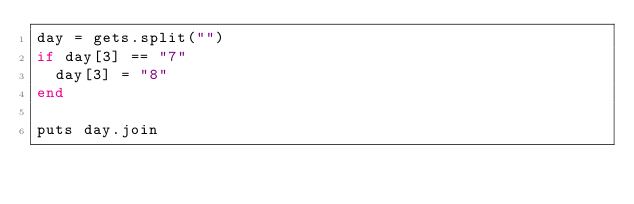<code> <loc_0><loc_0><loc_500><loc_500><_Ruby_>day = gets.split("")
if day[3] == "7"
  day[3] = "8"
end

puts day.join
</code> 